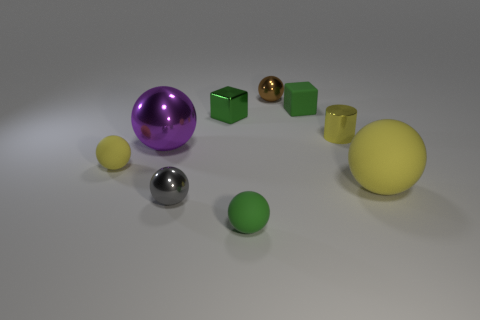Subtract all tiny gray spheres. How many spheres are left? 5 Subtract 5 spheres. How many spheres are left? 1 Subtract all green spheres. How many spheres are left? 5 Subtract 0 red spheres. How many objects are left? 9 Subtract all balls. How many objects are left? 3 Subtract all purple balls. Subtract all yellow blocks. How many balls are left? 5 Subtract all cyan blocks. How many green balls are left? 1 Subtract all tiny gray rubber cylinders. Subtract all tiny yellow balls. How many objects are left? 8 Add 4 yellow things. How many yellow things are left? 7 Add 8 large yellow matte objects. How many large yellow matte objects exist? 9 